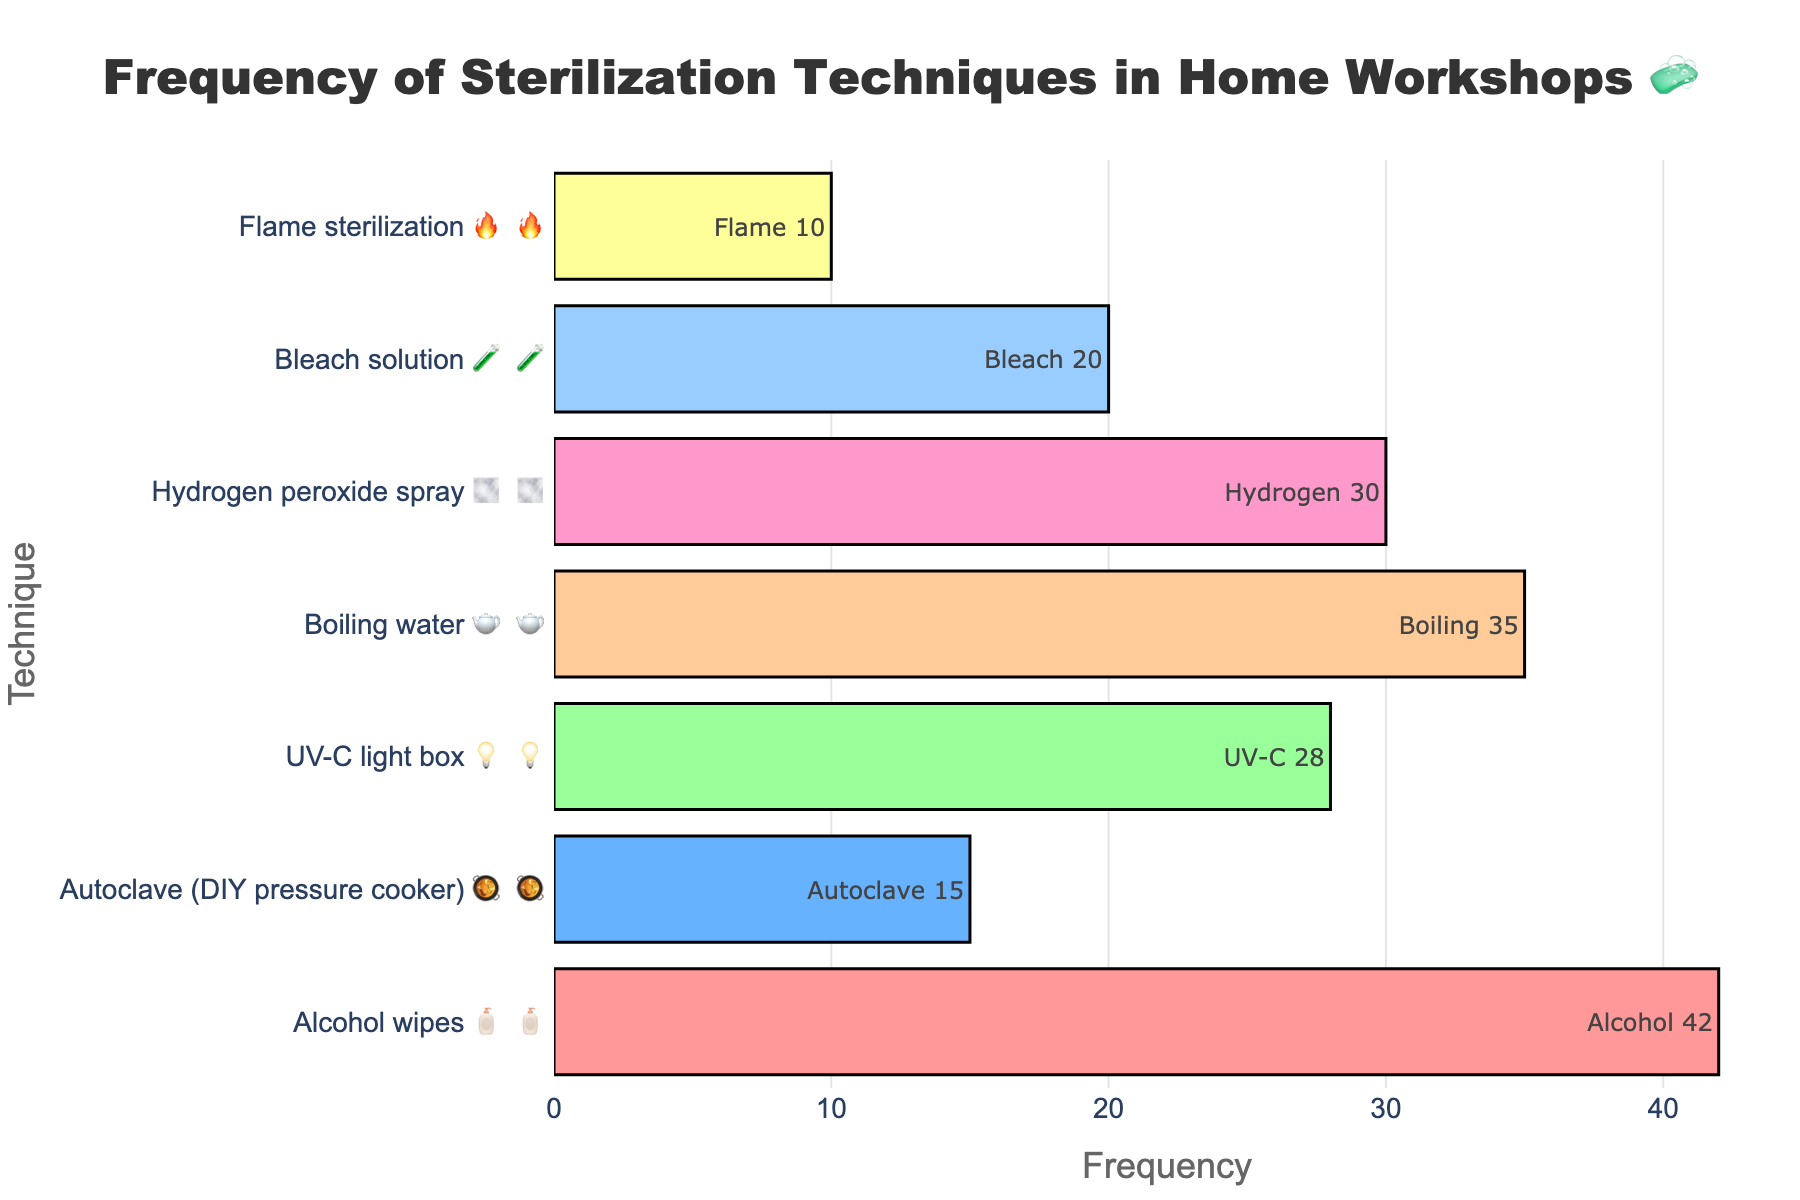what's the most frequently used sterilization technique? The figure shows that 'Alcohol wipes 🧴' has the highest frequency with 42 occurrences.
Answer: Alcohol wipes 🧴 How many sterilization techniques are there in total? By counting the distinct bars in the graph, we can see there are 7 different sterilization techniques.
Answer: 7 Which sterilization technique has the least frequency? The figure indicates that 'Flame sterilization 🔥' has the least frequency with 10 occurrences.
Answer: Flame sterilization 🔥 What is the combined frequency of 'Hydrogen peroxide spray 🌫️' and 'Bleach solution 🧪'? The frequencies of 'Hydrogen peroxide spray 🌫️' and 'Bleach solution 🧪' are 30 and 20, respectively. Summing these up gives 30 + 20 = 50.
Answer: 50 Is the frequency of 'Boiling water 🫖' less than or equal to 'UV-C light box 💡'? The frequency of 'Boiling water 🫖' is 35, and 'UV-C light box 💡' is 28. Thus, 35 is not less than or equal to 28.
Answer: No Among the techniques, which one uses a light as a sterilization method? By looking at the emojis and labels, we see that 'UV-C light box 💡' uses light for sterilization.
Answer: UV-C light box 💡 Calculate the average frequency of all the techniques. Summing all frequencies: 42 + 15 + 28 + 35 + 30 + 20 + 10 = 180. Then, dividing by the number of techniques (7): 180 / 7 ≈ 25.7.
Answer: 25.7 How much more frequently is 'Alcohol wipes 🧴' used compared to 'Flame sterilization 🔥'? 'Alcohol wipes 🧴' is used 42 times and 'Flame sterilization 🔥' is used 10 times. The difference is 42 - 10 = 32.
Answer: 32 What is the second least frequently used technique? After 'Flame sterilization 🔥' with 10 uses, the next least frequent is 'Autoclave (DIY pressure cooker) 🥘' with 15 uses.
Answer: Autoclave (DIY pressure cooker) 🥘 